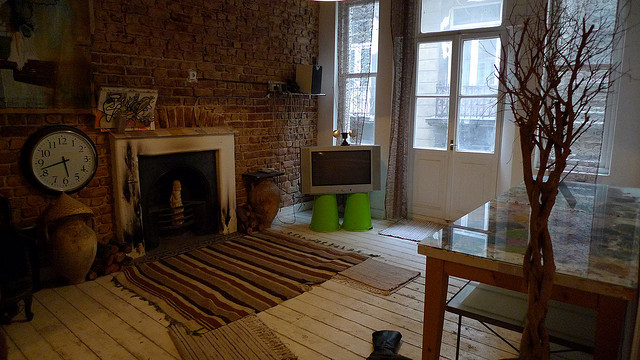Can you describe the style of the room shown in the image? The room has a cozy and rustic charm, with exposed brick walls and a traditional fireplace creating a warm atmosphere. The mismatched furnishings, including a simple wooden table and eclectic seating options, give the space a personalized touch. The large window lets in plenty of natural light, emphasizing the room's airy feel. 